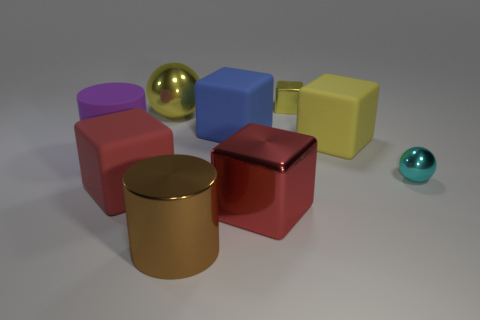Imagine these objects are part of a larger setting. What could that setting be? Given their simplified shapes and varying materials, these objects could belong to a digital rendering for a design concept, a visual representation in a learning module about geometry and physics, or even components of a modern art installation. 